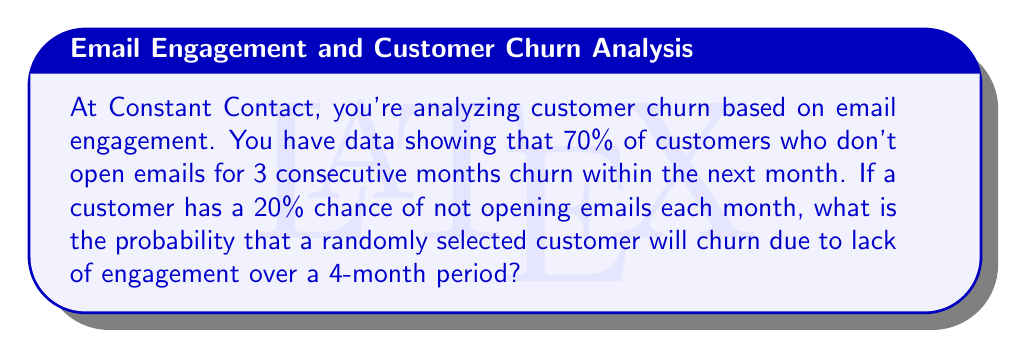Show me your answer to this math problem. Let's approach this step-by-step:

1) First, we need to calculate the probability of a customer not opening emails for 3 consecutive months.
   Let $p$ be the probability of not opening emails in a month.
   $p = 0.20$

   Probability of not opening for 3 consecutive months = $p^3 = 0.20^3 = 0.008$

2) Now, we know that if a customer doesn't open emails for 3 consecutive months, there's a 70% chance they'll churn in the next month.
   Let's call this probability $q$.
   $q = 0.70$

3) The probability of churning due to lack of engagement over a 4-month period is the product of:
   (Probability of not opening for 3 months) × (Probability of churning in the 4th month)

   $P(\text{churn}) = p^3 \times q = 0.008 \times 0.70 = 0.0056$

4) Therefore, the probability of a randomly selected customer churning due to lack of engagement over a 4-month period is 0.0056 or 0.56%.
Answer: 0.0056 